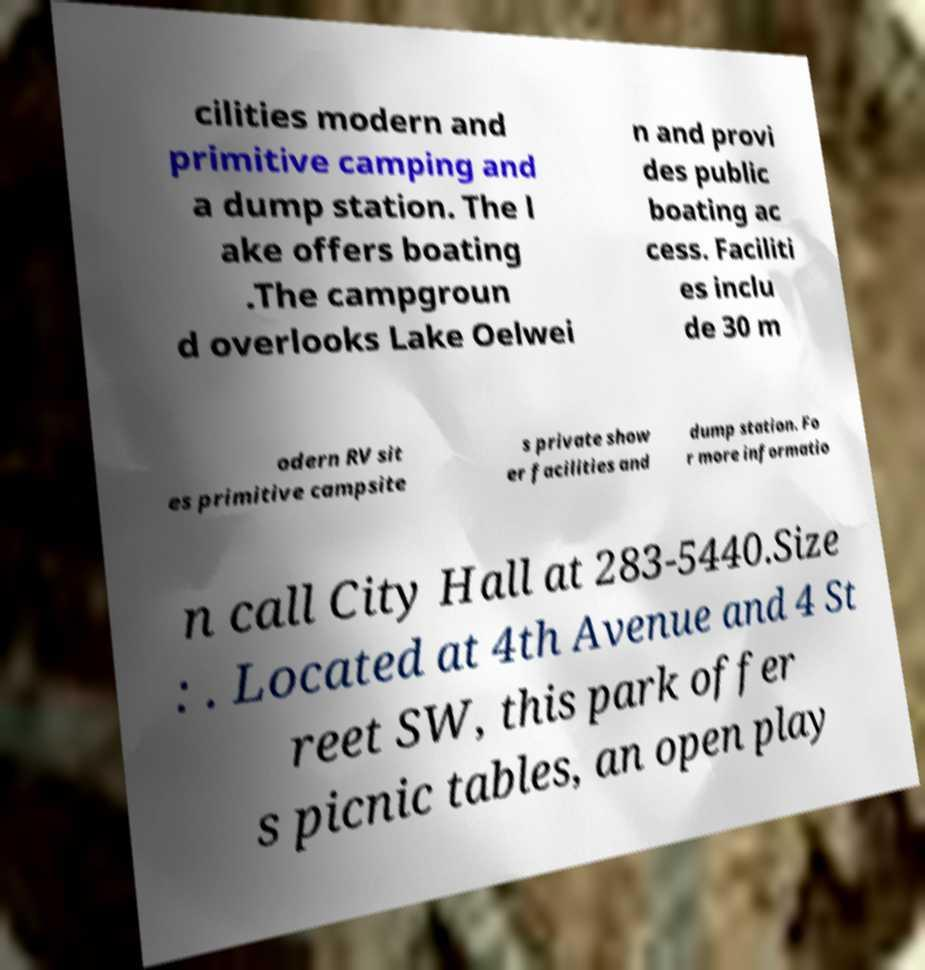I need the written content from this picture converted into text. Can you do that? cilities modern and primitive camping and a dump station. The l ake offers boating .The campgroun d overlooks Lake Oelwei n and provi des public boating ac cess. Faciliti es inclu de 30 m odern RV sit es primitive campsite s private show er facilities and dump station. Fo r more informatio n call City Hall at 283-5440.Size : . Located at 4th Avenue and 4 St reet SW, this park offer s picnic tables, an open play 